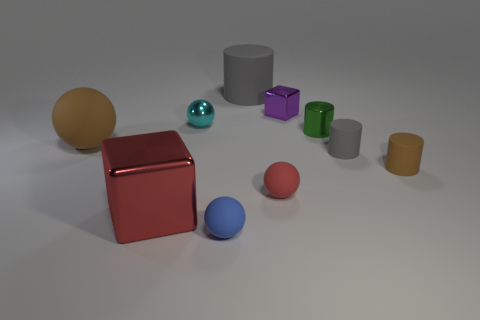Subtract all small brown rubber cylinders. How many cylinders are left? 3 Subtract all blue blocks. How many gray cylinders are left? 2 Subtract all blocks. How many objects are left? 8 Subtract 2 spheres. How many spheres are left? 2 Add 9 small red metal cubes. How many small red metal cubes exist? 9 Subtract all red blocks. How many blocks are left? 1 Subtract 1 purple blocks. How many objects are left? 9 Subtract all brown balls. Subtract all red cubes. How many balls are left? 3 Subtract all cyan blocks. Subtract all matte things. How many objects are left? 4 Add 7 gray rubber things. How many gray rubber things are left? 9 